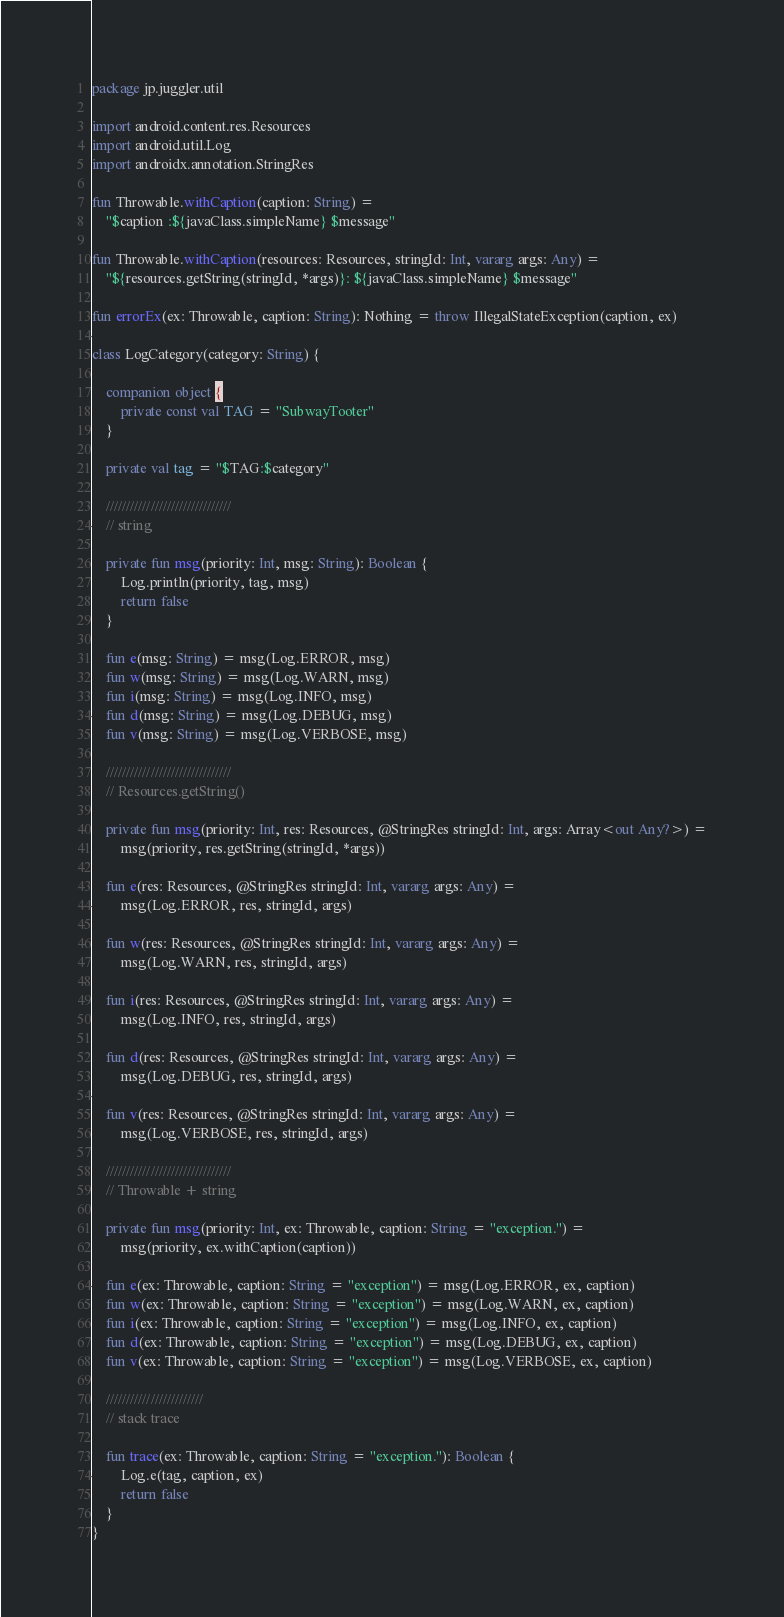<code> <loc_0><loc_0><loc_500><loc_500><_Kotlin_>package jp.juggler.util

import android.content.res.Resources
import android.util.Log
import androidx.annotation.StringRes

fun Throwable.withCaption(caption: String) =
    "$caption :${javaClass.simpleName} $message"

fun Throwable.withCaption(resources: Resources, stringId: Int, vararg args: Any) =
    "${resources.getString(stringId, *args)}: ${javaClass.simpleName} $message"

fun errorEx(ex: Throwable, caption: String): Nothing = throw IllegalStateException(caption, ex)

class LogCategory(category: String) {

    companion object {
        private const val TAG = "SubwayTooter"
    }

    private val tag = "$TAG:$category"

    ///////////////////////////////
    // string

    private fun msg(priority: Int, msg: String): Boolean {
        Log.println(priority, tag, msg)
        return false
    }

    fun e(msg: String) = msg(Log.ERROR, msg)
    fun w(msg: String) = msg(Log.WARN, msg)
    fun i(msg: String) = msg(Log.INFO, msg)
    fun d(msg: String) = msg(Log.DEBUG, msg)
    fun v(msg: String) = msg(Log.VERBOSE, msg)

    ///////////////////////////////
    // Resources.getString()

    private fun msg(priority: Int, res: Resources, @StringRes stringId: Int, args: Array<out Any?>) =
        msg(priority, res.getString(stringId, *args))

    fun e(res: Resources, @StringRes stringId: Int, vararg args: Any) =
        msg(Log.ERROR, res, stringId, args)

    fun w(res: Resources, @StringRes stringId: Int, vararg args: Any) =
        msg(Log.WARN, res, stringId, args)

    fun i(res: Resources, @StringRes stringId: Int, vararg args: Any) =
        msg(Log.INFO, res, stringId, args)

    fun d(res: Resources, @StringRes stringId: Int, vararg args: Any) =
        msg(Log.DEBUG, res, stringId, args)

    fun v(res: Resources, @StringRes stringId: Int, vararg args: Any) =
        msg(Log.VERBOSE, res, stringId, args)

    ///////////////////////////////
    // Throwable + string

    private fun msg(priority: Int, ex: Throwable, caption: String = "exception.") =
        msg(priority, ex.withCaption(caption))

    fun e(ex: Throwable, caption: String = "exception") = msg(Log.ERROR, ex, caption)
    fun w(ex: Throwable, caption: String = "exception") = msg(Log.WARN, ex, caption)
    fun i(ex: Throwable, caption: String = "exception") = msg(Log.INFO, ex, caption)
    fun d(ex: Throwable, caption: String = "exception") = msg(Log.DEBUG, ex, caption)
    fun v(ex: Throwable, caption: String = "exception") = msg(Log.VERBOSE, ex, caption)

    ////////////////////////
    // stack trace

    fun trace(ex: Throwable, caption: String = "exception."): Boolean {
        Log.e(tag, caption, ex)
        return false
    }
}
</code> 